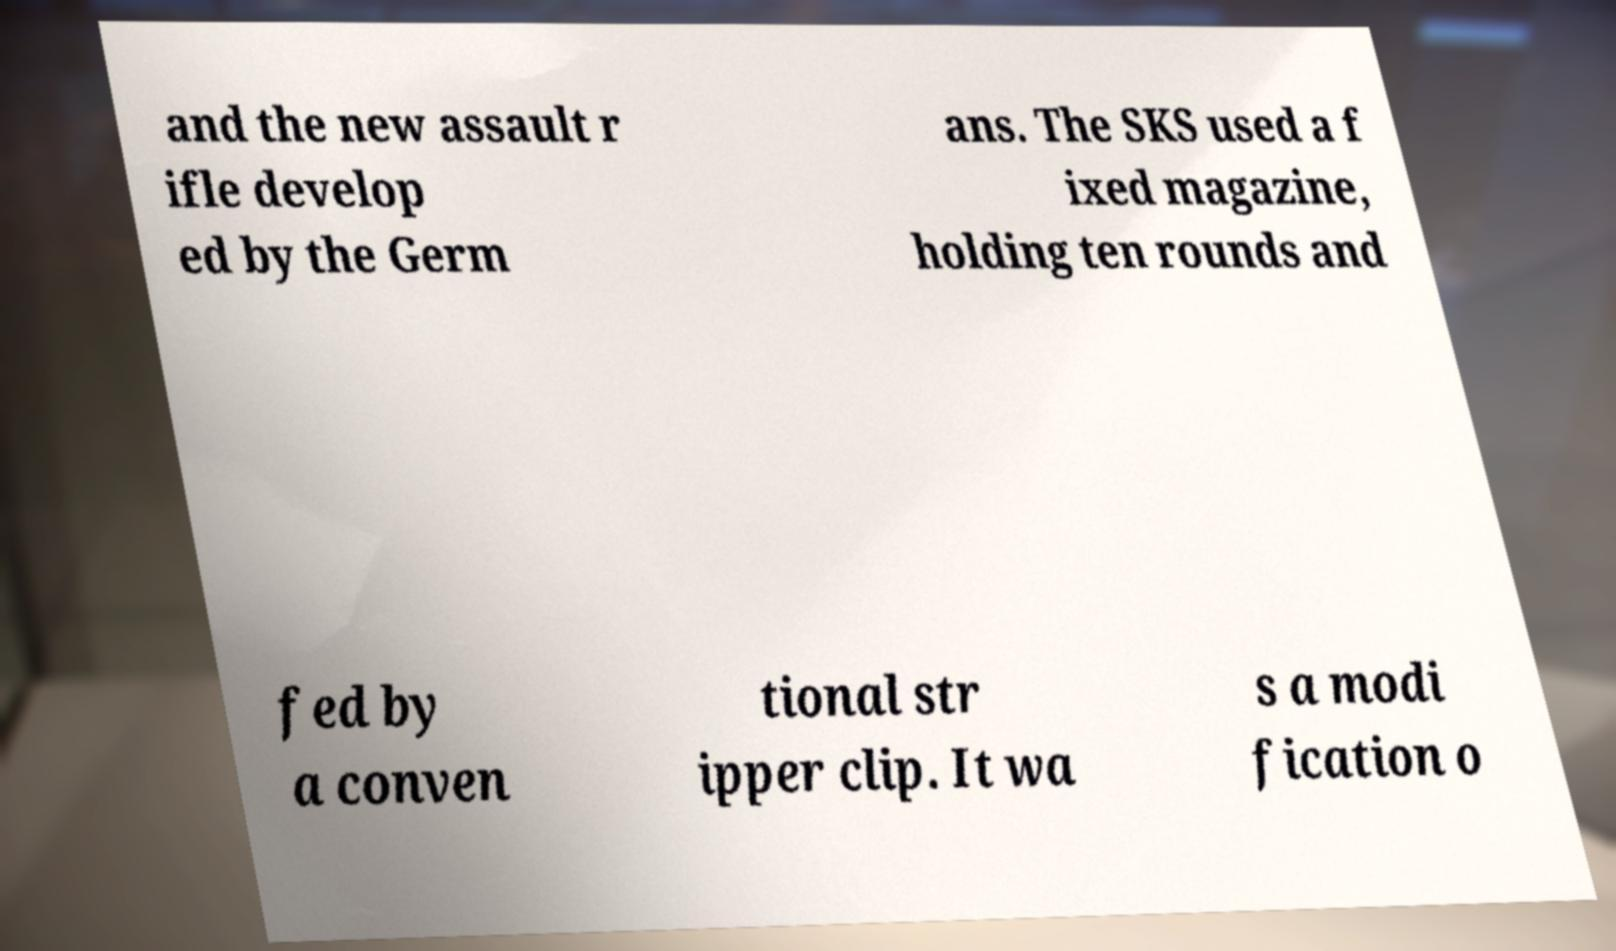What messages or text are displayed in this image? I need them in a readable, typed format. and the new assault r ifle develop ed by the Germ ans. The SKS used a f ixed magazine, holding ten rounds and fed by a conven tional str ipper clip. It wa s a modi fication o 